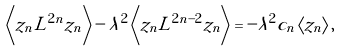<formula> <loc_0><loc_0><loc_500><loc_500>\left \langle z _ { n } L ^ { 2 n } z _ { n } \right \rangle - \lambda ^ { 2 } \left \langle z _ { n } L ^ { 2 n - 2 } z _ { n } \right \rangle = - \lambda ^ { 2 } c _ { n } \left \langle z _ { n } \right \rangle ,</formula> 